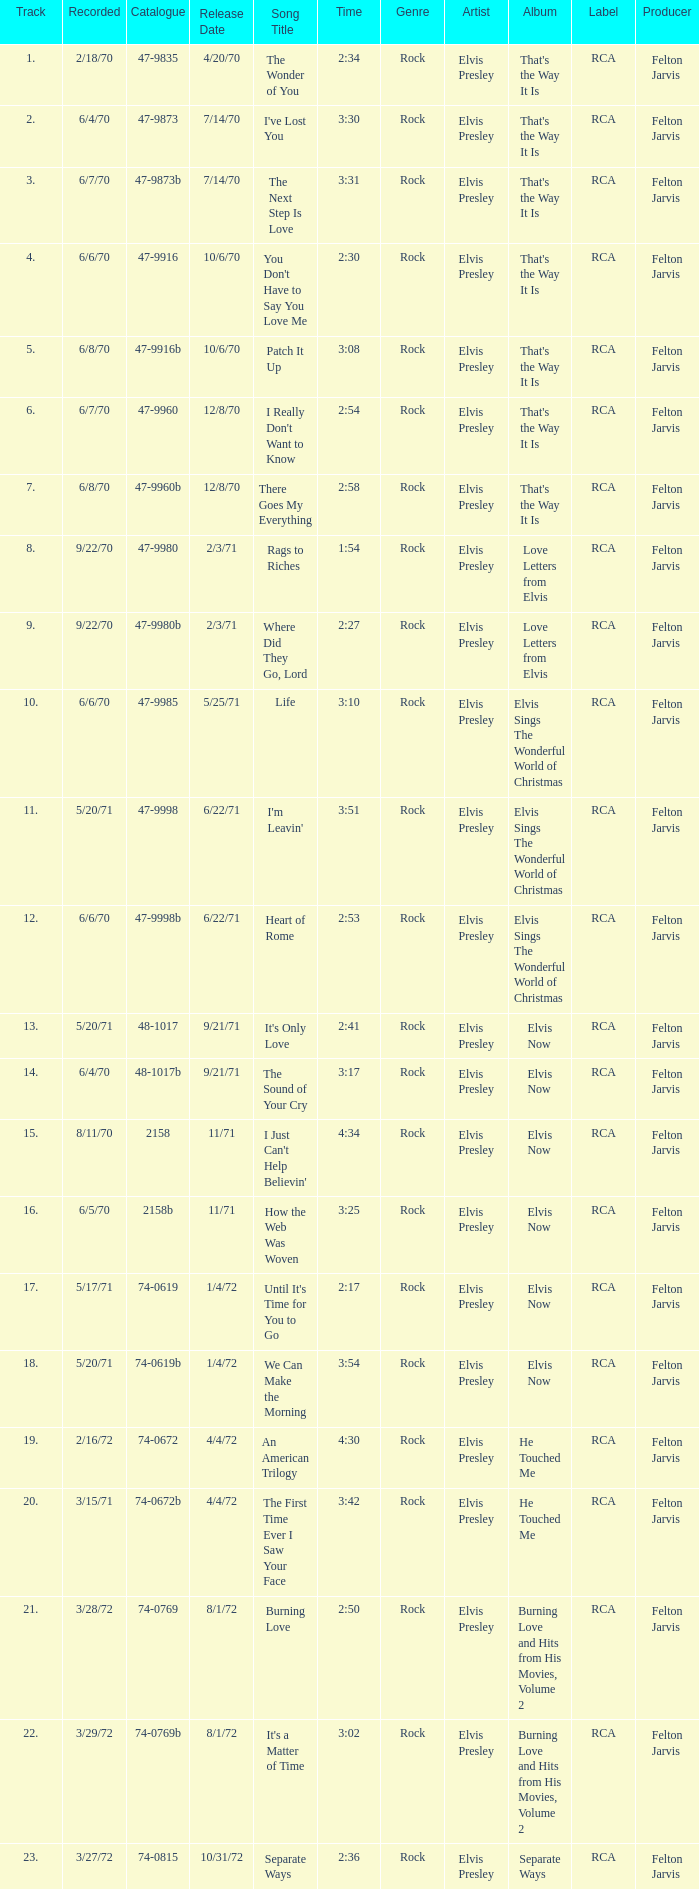Which song was released 12/8/70 with a time of 2:54? I Really Don't Want to Know. Give me the full table as a dictionary. {'header': ['Track', 'Recorded', 'Catalogue', 'Release Date', 'Song Title', 'Time', 'Genre', 'Artist', 'Album', 'Label', 'Producer'], 'rows': [['1.', '2/18/70', '47-9835', '4/20/70', 'The Wonder of You', '2:34', 'Rock', 'Elvis Presley', "That's the Way It Is", 'RCA', 'Felton Jarvis'], ['2.', '6/4/70', '47-9873', '7/14/70', "I've Lost You", '3:30', 'Rock', 'Elvis Presley', "That's the Way It Is", 'RCA', 'Felton Jarvis'], ['3.', '6/7/70', '47-9873b', '7/14/70', 'The Next Step Is Love', '3:31', 'Rock', 'Elvis Presley', "That's the Way It Is", 'RCA', 'Felton Jarvis'], ['4.', '6/6/70', '47-9916', '10/6/70', "You Don't Have to Say You Love Me", '2:30', 'Rock', 'Elvis Presley', "That's the Way It Is", 'RCA', 'Felton Jarvis'], ['5.', '6/8/70', '47-9916b', '10/6/70', 'Patch It Up', '3:08', 'Rock', 'Elvis Presley', "That's the Way It Is", 'RCA', 'Felton Jarvis'], ['6.', '6/7/70', '47-9960', '12/8/70', "I Really Don't Want to Know", '2:54', 'Rock', 'Elvis Presley', "That's the Way It Is", 'RCA', 'Felton Jarvis'], ['7.', '6/8/70', '47-9960b', '12/8/70', 'There Goes My Everything', '2:58', 'Rock', 'Elvis Presley', "That's the Way It Is", 'RCA', 'Felton Jarvis'], ['8.', '9/22/70', '47-9980', '2/3/71', 'Rags to Riches', '1:54', 'Rock', 'Elvis Presley', 'Love Letters from Elvis', 'RCA', 'Felton Jarvis'], ['9.', '9/22/70', '47-9980b', '2/3/71', 'Where Did They Go, Lord', '2:27', 'Rock', 'Elvis Presley', 'Love Letters from Elvis', 'RCA', 'Felton Jarvis'], ['10.', '6/6/70', '47-9985', '5/25/71', 'Life', '3:10', 'Rock', 'Elvis Presley', 'Elvis Sings The Wonderful World of Christmas', 'RCA', 'Felton Jarvis'], ['11.', '5/20/71', '47-9998', '6/22/71', "I'm Leavin'", '3:51', 'Rock', 'Elvis Presley', 'Elvis Sings The Wonderful World of Christmas', 'RCA', 'Felton Jarvis'], ['12.', '6/6/70', '47-9998b', '6/22/71', 'Heart of Rome', '2:53', 'Rock', 'Elvis Presley', 'Elvis Sings The Wonderful World of Christmas', 'RCA', 'Felton Jarvis'], ['13.', '5/20/71', '48-1017', '9/21/71', "It's Only Love", '2:41', 'Rock', 'Elvis Presley', 'Elvis Now', 'RCA', 'Felton Jarvis'], ['14.', '6/4/70', '48-1017b', '9/21/71', 'The Sound of Your Cry', '3:17', 'Rock', 'Elvis Presley', 'Elvis Now', 'RCA', 'Felton Jarvis'], ['15.', '8/11/70', '2158', '11/71', "I Just Can't Help Believin'", '4:34', 'Rock', 'Elvis Presley', 'Elvis Now', 'RCA', 'Felton Jarvis'], ['16.', '6/5/70', '2158b', '11/71', 'How the Web Was Woven', '3:25', 'Rock', 'Elvis Presley', 'Elvis Now', 'RCA', 'Felton Jarvis'], ['17.', '5/17/71', '74-0619', '1/4/72', "Until It's Time for You to Go", '2:17', 'Rock', 'Elvis Presley', 'Elvis Now', 'RCA', 'Felton Jarvis'], ['18.', '5/20/71', '74-0619b', '1/4/72', 'We Can Make the Morning', '3:54', 'Rock', 'Elvis Presley', 'Elvis Now', 'RCA', 'Felton Jarvis'], ['19.', '2/16/72', '74-0672', '4/4/72', 'An American Trilogy', '4:30', 'Rock', 'Elvis Presley', 'He Touched Me', 'RCA', 'Felton Jarvis'], ['20.', '3/15/71', '74-0672b', '4/4/72', 'The First Time Ever I Saw Your Face', '3:42', 'Rock', 'Elvis Presley', 'He Touched Me', 'RCA', 'Felton Jarvis'], ['21.', '3/28/72', '74-0769', '8/1/72', 'Burning Love', '2:50', 'Rock', 'Elvis Presley', 'Burning Love and Hits from His Movies, Volume 2', 'RCA', 'Felton Jarvis'], ['22.', '3/29/72', '74-0769b', '8/1/72', "It's a Matter of Time", '3:02', 'Rock', 'Elvis Presley', 'Burning Love and Hits from His Movies, Volume 2', 'RCA', 'Felton Jarvis'], ['23.', '3/27/72', '74-0815', '10/31/72', 'Separate Ways', '2:36', 'Rock', 'Elvis Presley', 'Separate Ways', 'RCA', 'Felton Jarvis']]} 